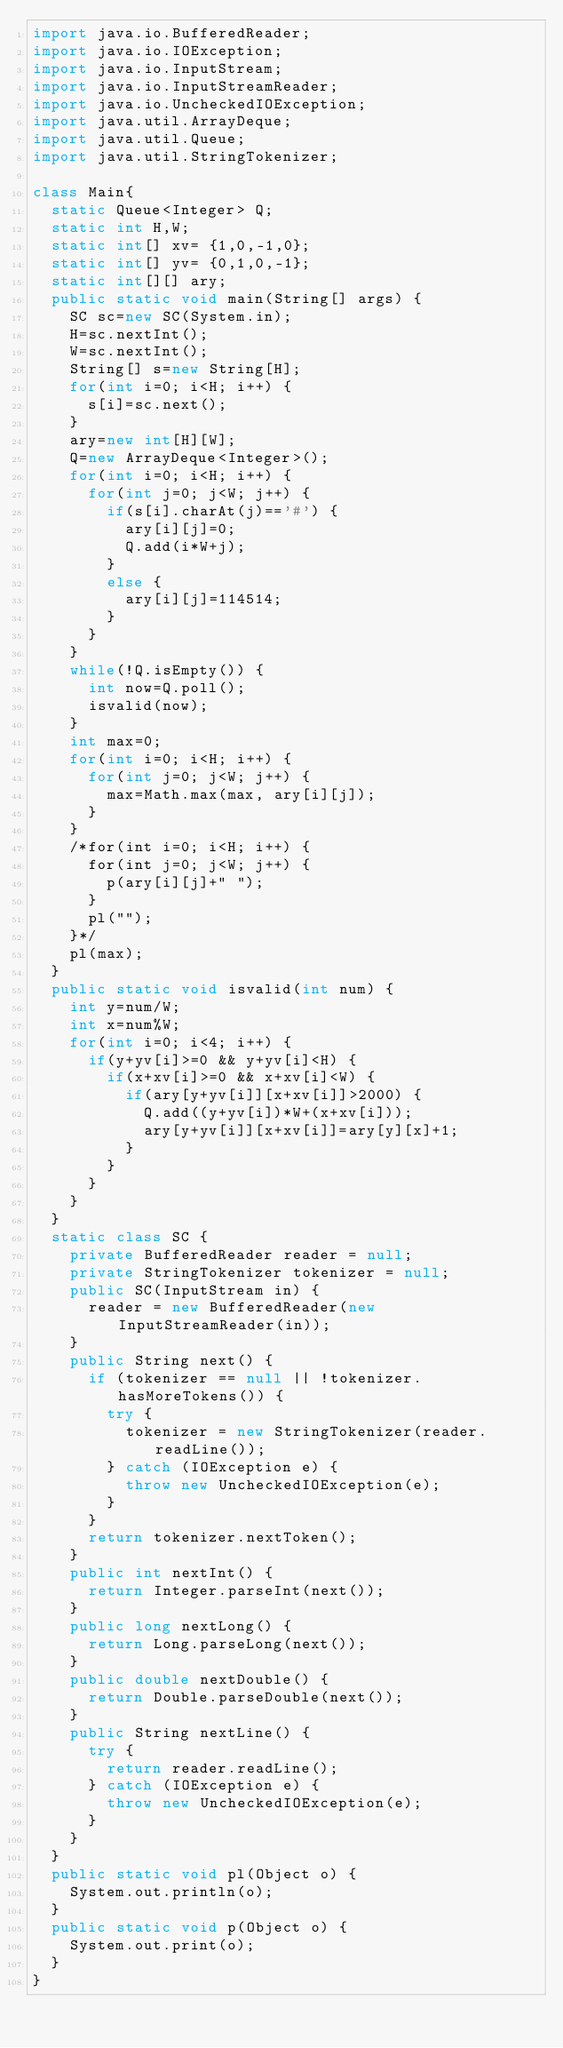Convert code to text. <code><loc_0><loc_0><loc_500><loc_500><_Java_>import java.io.BufferedReader;
import java.io.IOException;
import java.io.InputStream;
import java.io.InputStreamReader;
import java.io.UncheckedIOException;
import java.util.ArrayDeque;
import java.util.Queue;
import java.util.StringTokenizer;

class Main{
	static Queue<Integer> Q;
	static int H,W;
	static int[] xv= {1,0,-1,0};
	static int[] yv= {0,1,0,-1};
	static int[][] ary;
	public static void main(String[] args) {
		SC sc=new SC(System.in);
		H=sc.nextInt();
		W=sc.nextInt();
		String[] s=new String[H];
		for(int i=0; i<H; i++) {
			s[i]=sc.next();
		}
		ary=new int[H][W];
		Q=new ArrayDeque<Integer>();
		for(int i=0; i<H; i++) {
			for(int j=0; j<W; j++) {
				if(s[i].charAt(j)=='#') {
					ary[i][j]=0;
					Q.add(i*W+j);
				}
				else {
					ary[i][j]=114514;
				}
			}
		}
		while(!Q.isEmpty()) {
			int now=Q.poll();
			isvalid(now);
		}
		int max=0;
		for(int i=0; i<H; i++) {
			for(int j=0; j<W; j++) {
				max=Math.max(max, ary[i][j]);
			}
		}
		/*for(int i=0; i<H; i++) {
			for(int j=0; j<W; j++) {
				p(ary[i][j]+" ");
			}
			pl("");
		}*/
		pl(max);
	}
	public static void isvalid(int num) {
		int y=num/W;
		int x=num%W;
		for(int i=0; i<4; i++) {
			if(y+yv[i]>=0 && y+yv[i]<H) {
				if(x+xv[i]>=0 && x+xv[i]<W) {
					if(ary[y+yv[i]][x+xv[i]]>2000) {
						Q.add((y+yv[i])*W+(x+xv[i]));
						ary[y+yv[i]][x+xv[i]]=ary[y][x]+1;
					}
				}
			}
		}
	}
	static class SC {
		private BufferedReader reader = null;
		private StringTokenizer tokenizer = null;
		public SC(InputStream in) {
			reader = new BufferedReader(new InputStreamReader(in));
		}
		public String next() {
			if (tokenizer == null || !tokenizer.hasMoreTokens()) {
				try {
					tokenizer = new StringTokenizer(reader.readLine());
				} catch (IOException e) {
					throw new UncheckedIOException(e);
				}
			}
			return tokenizer.nextToken();
		}
		public int nextInt() {
			return Integer.parseInt(next());
		}
		public long nextLong() {
			return Long.parseLong(next());
		}
		public double nextDouble() {
			return Double.parseDouble(next());
		}
		public String nextLine() {
			try {
				return reader.readLine();
			} catch (IOException e) {
				throw new UncheckedIOException(e);
			}
		}
	}
	public static void pl(Object o) {
		System.out.println(o);
	}
	public static void p(Object o) {
		System.out.print(o);
	}
}
</code> 